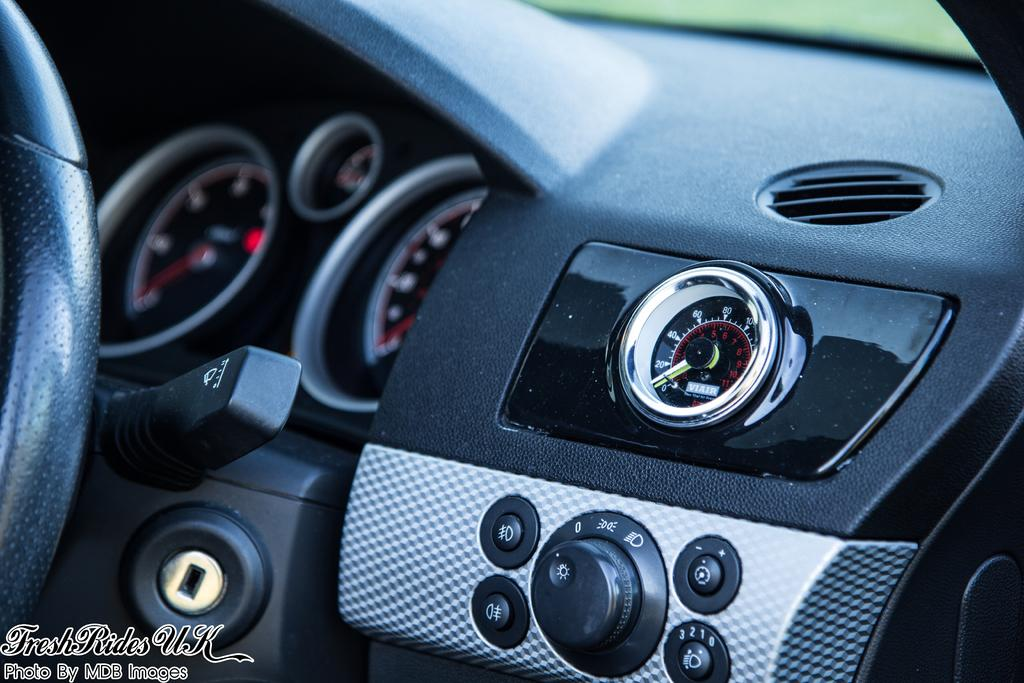What type of setting is depicted in the image? The image shows the interior of a motor vehicle. What type of insurance policy is required for the coach in the image? There is no coach present in the image, and therefore no insurance policy is relevant. 